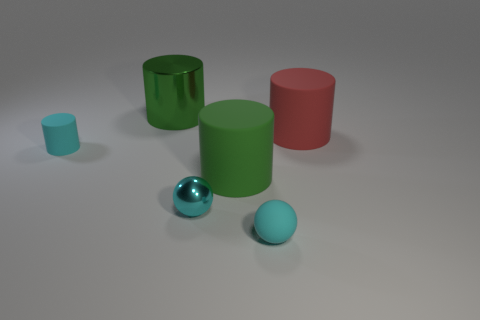There is a green cylinder in front of the tiny cyan cylinder; what is its material? The green cylinder appears to be made of a matte material, which could likely be plastic based on the lack of reflective properties that materials such as metal or glass would exhibit. 